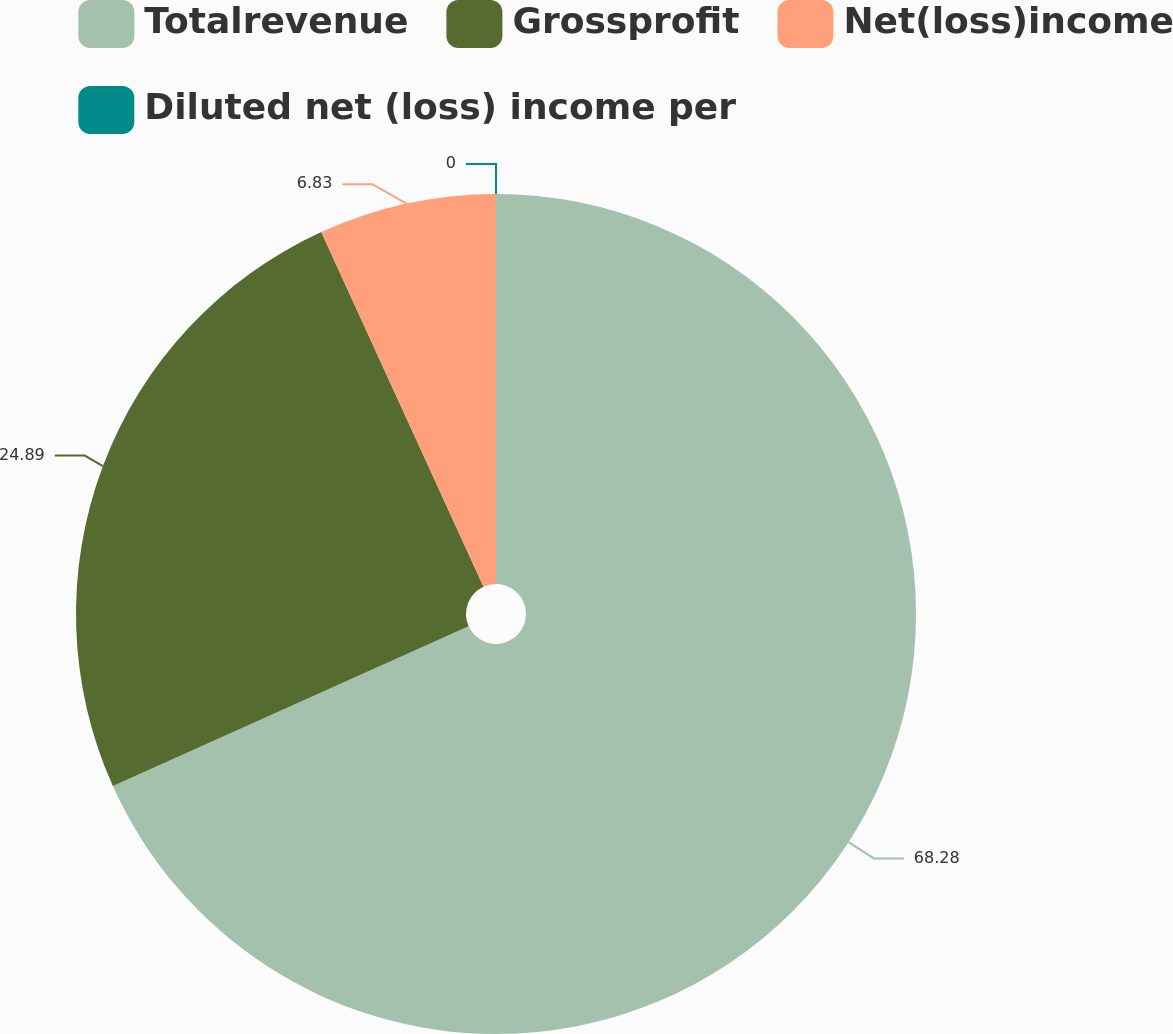Convert chart to OTSL. <chart><loc_0><loc_0><loc_500><loc_500><pie_chart><fcel>Totalrevenue<fcel>Grossprofit<fcel>Net(loss)income<fcel>Diluted net (loss) income per<nl><fcel>68.28%<fcel>24.89%<fcel>6.83%<fcel>0.0%<nl></chart> 